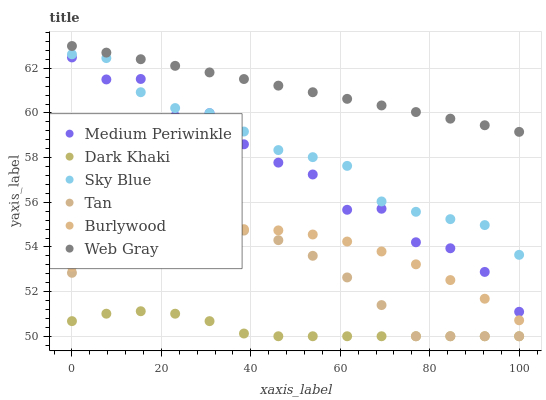Does Dark Khaki have the minimum area under the curve?
Answer yes or no. Yes. Does Web Gray have the maximum area under the curve?
Answer yes or no. Yes. Does Burlywood have the minimum area under the curve?
Answer yes or no. No. Does Burlywood have the maximum area under the curve?
Answer yes or no. No. Is Web Gray the smoothest?
Answer yes or no. Yes. Is Medium Periwinkle the roughest?
Answer yes or no. Yes. Is Burlywood the smoothest?
Answer yes or no. No. Is Burlywood the roughest?
Answer yes or no. No. Does Dark Khaki have the lowest value?
Answer yes or no. Yes. Does Burlywood have the lowest value?
Answer yes or no. No. Does Web Gray have the highest value?
Answer yes or no. Yes. Does Burlywood have the highest value?
Answer yes or no. No. Is Burlywood less than Web Gray?
Answer yes or no. Yes. Is Medium Periwinkle greater than Tan?
Answer yes or no. Yes. Does Sky Blue intersect Medium Periwinkle?
Answer yes or no. Yes. Is Sky Blue less than Medium Periwinkle?
Answer yes or no. No. Is Sky Blue greater than Medium Periwinkle?
Answer yes or no. No. Does Burlywood intersect Web Gray?
Answer yes or no. No. 